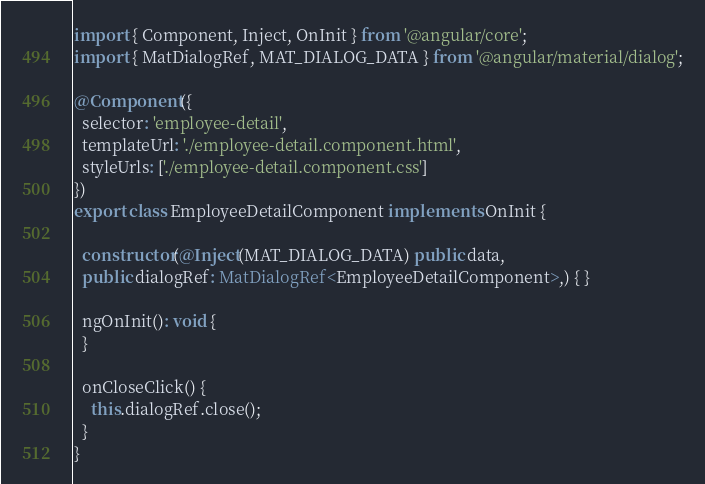<code> <loc_0><loc_0><loc_500><loc_500><_TypeScript_>import { Component, Inject, OnInit } from '@angular/core';
import { MatDialogRef, MAT_DIALOG_DATA } from '@angular/material/dialog';

@Component({
  selector: 'employee-detail',
  templateUrl: './employee-detail.component.html',
  styleUrls: ['./employee-detail.component.css']
})
export class EmployeeDetailComponent implements OnInit {

  constructor(@Inject(MAT_DIALOG_DATA) public data,
  public dialogRef: MatDialogRef<EmployeeDetailComponent>,) { }

  ngOnInit(): void {
  }

  onCloseClick() {
    this.dialogRef.close();
  }
}
</code> 